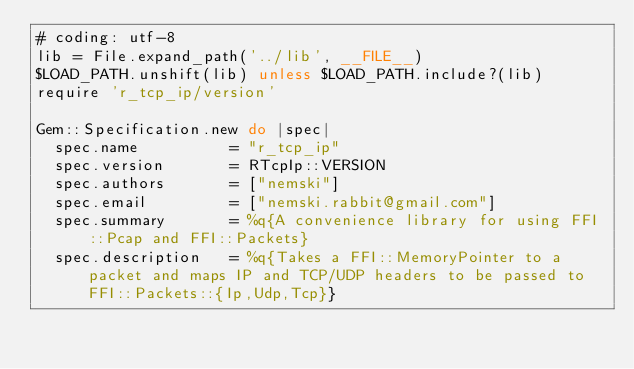Convert code to text. <code><loc_0><loc_0><loc_500><loc_500><_Ruby_># coding: utf-8
lib = File.expand_path('../lib', __FILE__)
$LOAD_PATH.unshift(lib) unless $LOAD_PATH.include?(lib)
require 'r_tcp_ip/version'

Gem::Specification.new do |spec|
  spec.name          = "r_tcp_ip"
  spec.version       = RTcpIp::VERSION
  spec.authors       = ["nemski"]
  spec.email         = ["nemski.rabbit@gmail.com"]
  spec.summary       = %q{A convenience library for using FFI::Pcap and FFI::Packets}
  spec.description   = %q{Takes a FFI::MemoryPointer to a packet and maps IP and TCP/UDP headers to be passed to FFI::Packets::{Ip,Udp,Tcp}}</code> 